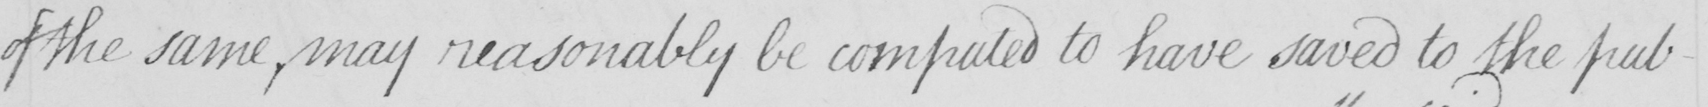What does this handwritten line say? of the same  , may reasonably be computed to have saved to the pub- 